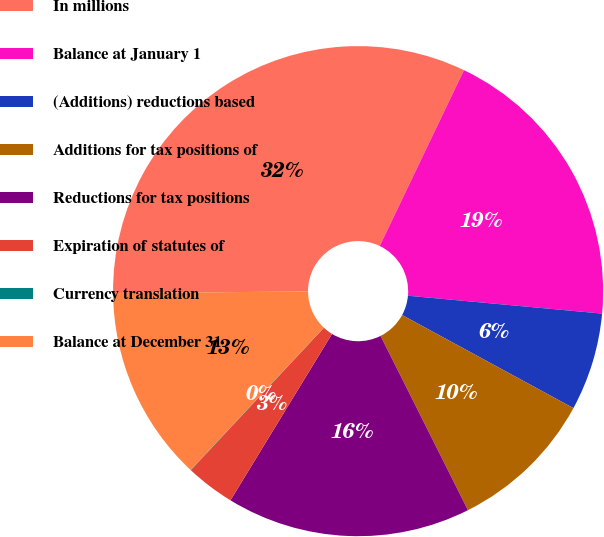Convert chart. <chart><loc_0><loc_0><loc_500><loc_500><pie_chart><fcel>In millions<fcel>Balance at January 1<fcel>(Additions) reductions based<fcel>Additions for tax positions of<fcel>Reductions for tax positions<fcel>Expiration of statutes of<fcel>Currency translation<fcel>Balance at December 31<nl><fcel>32.23%<fcel>19.35%<fcel>6.46%<fcel>9.68%<fcel>16.12%<fcel>3.24%<fcel>0.02%<fcel>12.9%<nl></chart> 